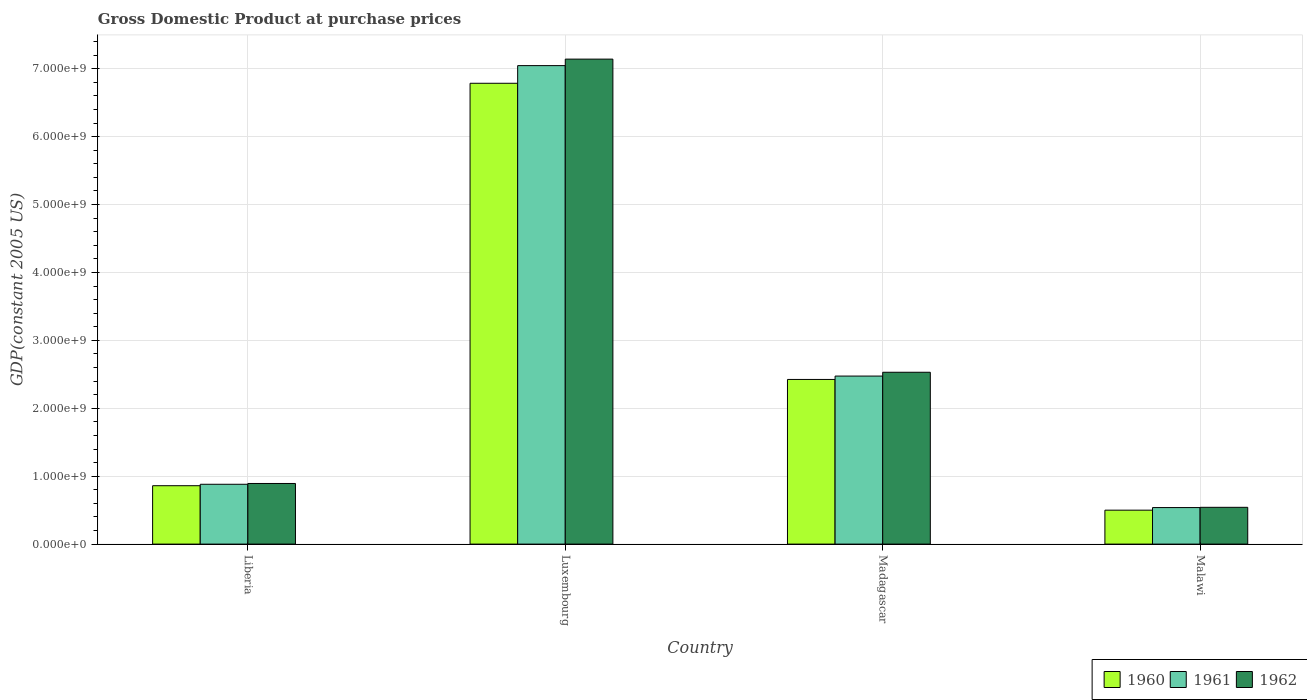How many different coloured bars are there?
Your answer should be very brief. 3. Are the number of bars per tick equal to the number of legend labels?
Keep it short and to the point. Yes. Are the number of bars on each tick of the X-axis equal?
Keep it short and to the point. Yes. How many bars are there on the 1st tick from the left?
Make the answer very short. 3. How many bars are there on the 2nd tick from the right?
Your answer should be very brief. 3. What is the label of the 4th group of bars from the left?
Provide a succinct answer. Malawi. What is the GDP at purchase prices in 1961 in Malawi?
Give a very brief answer. 5.38e+08. Across all countries, what is the maximum GDP at purchase prices in 1961?
Offer a terse response. 7.05e+09. Across all countries, what is the minimum GDP at purchase prices in 1961?
Offer a terse response. 5.38e+08. In which country was the GDP at purchase prices in 1962 maximum?
Make the answer very short. Luxembourg. In which country was the GDP at purchase prices in 1960 minimum?
Offer a terse response. Malawi. What is the total GDP at purchase prices in 1961 in the graph?
Provide a succinct answer. 1.09e+1. What is the difference between the GDP at purchase prices in 1961 in Luxembourg and that in Malawi?
Offer a terse response. 6.51e+09. What is the difference between the GDP at purchase prices in 1961 in Madagascar and the GDP at purchase prices in 1962 in Liberia?
Provide a short and direct response. 1.58e+09. What is the average GDP at purchase prices in 1961 per country?
Keep it short and to the point. 2.73e+09. What is the difference between the GDP at purchase prices of/in 1961 and GDP at purchase prices of/in 1962 in Madagascar?
Ensure brevity in your answer.  -5.62e+07. In how many countries, is the GDP at purchase prices in 1961 greater than 2800000000 US$?
Keep it short and to the point. 1. What is the ratio of the GDP at purchase prices in 1962 in Liberia to that in Luxembourg?
Your response must be concise. 0.13. Is the GDP at purchase prices in 1962 in Liberia less than that in Madagascar?
Offer a terse response. Yes. What is the difference between the highest and the second highest GDP at purchase prices in 1960?
Give a very brief answer. 1.56e+09. What is the difference between the highest and the lowest GDP at purchase prices in 1960?
Offer a terse response. 6.29e+09. In how many countries, is the GDP at purchase prices in 1960 greater than the average GDP at purchase prices in 1960 taken over all countries?
Offer a terse response. 1. Is the sum of the GDP at purchase prices in 1961 in Liberia and Luxembourg greater than the maximum GDP at purchase prices in 1960 across all countries?
Your answer should be compact. Yes. What does the 3rd bar from the right in Liberia represents?
Give a very brief answer. 1960. Is it the case that in every country, the sum of the GDP at purchase prices in 1962 and GDP at purchase prices in 1960 is greater than the GDP at purchase prices in 1961?
Keep it short and to the point. Yes. How many bars are there?
Make the answer very short. 12. How many countries are there in the graph?
Your answer should be compact. 4. What is the difference between two consecutive major ticks on the Y-axis?
Ensure brevity in your answer.  1.00e+09. Does the graph contain any zero values?
Your answer should be very brief. No. Where does the legend appear in the graph?
Provide a short and direct response. Bottom right. What is the title of the graph?
Offer a very short reply. Gross Domestic Product at purchase prices. What is the label or title of the X-axis?
Provide a succinct answer. Country. What is the label or title of the Y-axis?
Provide a short and direct response. GDP(constant 2005 US). What is the GDP(constant 2005 US) of 1960 in Liberia?
Your answer should be very brief. 8.60e+08. What is the GDP(constant 2005 US) of 1961 in Liberia?
Make the answer very short. 8.81e+08. What is the GDP(constant 2005 US) in 1962 in Liberia?
Make the answer very short. 8.93e+08. What is the GDP(constant 2005 US) in 1960 in Luxembourg?
Offer a very short reply. 6.79e+09. What is the GDP(constant 2005 US) in 1961 in Luxembourg?
Provide a succinct answer. 7.05e+09. What is the GDP(constant 2005 US) in 1962 in Luxembourg?
Make the answer very short. 7.14e+09. What is the GDP(constant 2005 US) in 1960 in Madagascar?
Give a very brief answer. 2.42e+09. What is the GDP(constant 2005 US) of 1961 in Madagascar?
Provide a short and direct response. 2.47e+09. What is the GDP(constant 2005 US) of 1962 in Madagascar?
Offer a very short reply. 2.53e+09. What is the GDP(constant 2005 US) of 1960 in Malawi?
Ensure brevity in your answer.  5.00e+08. What is the GDP(constant 2005 US) in 1961 in Malawi?
Provide a succinct answer. 5.38e+08. What is the GDP(constant 2005 US) in 1962 in Malawi?
Provide a short and direct response. 5.42e+08. Across all countries, what is the maximum GDP(constant 2005 US) of 1960?
Offer a very short reply. 6.79e+09. Across all countries, what is the maximum GDP(constant 2005 US) of 1961?
Provide a short and direct response. 7.05e+09. Across all countries, what is the maximum GDP(constant 2005 US) in 1962?
Make the answer very short. 7.14e+09. Across all countries, what is the minimum GDP(constant 2005 US) of 1960?
Give a very brief answer. 5.00e+08. Across all countries, what is the minimum GDP(constant 2005 US) in 1961?
Give a very brief answer. 5.38e+08. Across all countries, what is the minimum GDP(constant 2005 US) of 1962?
Your answer should be very brief. 5.42e+08. What is the total GDP(constant 2005 US) of 1960 in the graph?
Give a very brief answer. 1.06e+1. What is the total GDP(constant 2005 US) of 1961 in the graph?
Keep it short and to the point. 1.09e+1. What is the total GDP(constant 2005 US) in 1962 in the graph?
Your answer should be compact. 1.11e+1. What is the difference between the GDP(constant 2005 US) in 1960 in Liberia and that in Luxembourg?
Offer a very short reply. -5.93e+09. What is the difference between the GDP(constant 2005 US) in 1961 in Liberia and that in Luxembourg?
Your response must be concise. -6.16e+09. What is the difference between the GDP(constant 2005 US) in 1962 in Liberia and that in Luxembourg?
Provide a succinct answer. -6.25e+09. What is the difference between the GDP(constant 2005 US) in 1960 in Liberia and that in Madagascar?
Keep it short and to the point. -1.56e+09. What is the difference between the GDP(constant 2005 US) in 1961 in Liberia and that in Madagascar?
Ensure brevity in your answer.  -1.59e+09. What is the difference between the GDP(constant 2005 US) of 1962 in Liberia and that in Madagascar?
Ensure brevity in your answer.  -1.64e+09. What is the difference between the GDP(constant 2005 US) of 1960 in Liberia and that in Malawi?
Ensure brevity in your answer.  3.60e+08. What is the difference between the GDP(constant 2005 US) in 1961 in Liberia and that in Malawi?
Provide a succinct answer. 3.43e+08. What is the difference between the GDP(constant 2005 US) of 1962 in Liberia and that in Malawi?
Make the answer very short. 3.51e+08. What is the difference between the GDP(constant 2005 US) in 1960 in Luxembourg and that in Madagascar?
Offer a terse response. 4.36e+09. What is the difference between the GDP(constant 2005 US) of 1961 in Luxembourg and that in Madagascar?
Provide a short and direct response. 4.57e+09. What is the difference between the GDP(constant 2005 US) of 1962 in Luxembourg and that in Madagascar?
Provide a short and direct response. 4.61e+09. What is the difference between the GDP(constant 2005 US) of 1960 in Luxembourg and that in Malawi?
Make the answer very short. 6.29e+09. What is the difference between the GDP(constant 2005 US) in 1961 in Luxembourg and that in Malawi?
Your answer should be very brief. 6.51e+09. What is the difference between the GDP(constant 2005 US) in 1962 in Luxembourg and that in Malawi?
Your answer should be very brief. 6.60e+09. What is the difference between the GDP(constant 2005 US) of 1960 in Madagascar and that in Malawi?
Your answer should be very brief. 1.92e+09. What is the difference between the GDP(constant 2005 US) in 1961 in Madagascar and that in Malawi?
Make the answer very short. 1.94e+09. What is the difference between the GDP(constant 2005 US) in 1962 in Madagascar and that in Malawi?
Offer a terse response. 1.99e+09. What is the difference between the GDP(constant 2005 US) in 1960 in Liberia and the GDP(constant 2005 US) in 1961 in Luxembourg?
Keep it short and to the point. -6.19e+09. What is the difference between the GDP(constant 2005 US) of 1960 in Liberia and the GDP(constant 2005 US) of 1962 in Luxembourg?
Your response must be concise. -6.28e+09. What is the difference between the GDP(constant 2005 US) in 1961 in Liberia and the GDP(constant 2005 US) in 1962 in Luxembourg?
Offer a very short reply. -6.26e+09. What is the difference between the GDP(constant 2005 US) in 1960 in Liberia and the GDP(constant 2005 US) in 1961 in Madagascar?
Your answer should be very brief. -1.61e+09. What is the difference between the GDP(constant 2005 US) in 1960 in Liberia and the GDP(constant 2005 US) in 1962 in Madagascar?
Give a very brief answer. -1.67e+09. What is the difference between the GDP(constant 2005 US) in 1961 in Liberia and the GDP(constant 2005 US) in 1962 in Madagascar?
Ensure brevity in your answer.  -1.65e+09. What is the difference between the GDP(constant 2005 US) of 1960 in Liberia and the GDP(constant 2005 US) of 1961 in Malawi?
Make the answer very short. 3.22e+08. What is the difference between the GDP(constant 2005 US) in 1960 in Liberia and the GDP(constant 2005 US) in 1962 in Malawi?
Provide a short and direct response. 3.18e+08. What is the difference between the GDP(constant 2005 US) of 1961 in Liberia and the GDP(constant 2005 US) of 1962 in Malawi?
Your response must be concise. 3.39e+08. What is the difference between the GDP(constant 2005 US) of 1960 in Luxembourg and the GDP(constant 2005 US) of 1961 in Madagascar?
Give a very brief answer. 4.31e+09. What is the difference between the GDP(constant 2005 US) of 1960 in Luxembourg and the GDP(constant 2005 US) of 1962 in Madagascar?
Your answer should be very brief. 4.26e+09. What is the difference between the GDP(constant 2005 US) in 1961 in Luxembourg and the GDP(constant 2005 US) in 1962 in Madagascar?
Offer a very short reply. 4.52e+09. What is the difference between the GDP(constant 2005 US) in 1960 in Luxembourg and the GDP(constant 2005 US) in 1961 in Malawi?
Your answer should be compact. 6.25e+09. What is the difference between the GDP(constant 2005 US) of 1960 in Luxembourg and the GDP(constant 2005 US) of 1962 in Malawi?
Provide a succinct answer. 6.24e+09. What is the difference between the GDP(constant 2005 US) in 1961 in Luxembourg and the GDP(constant 2005 US) in 1962 in Malawi?
Ensure brevity in your answer.  6.50e+09. What is the difference between the GDP(constant 2005 US) in 1960 in Madagascar and the GDP(constant 2005 US) in 1961 in Malawi?
Your answer should be very brief. 1.89e+09. What is the difference between the GDP(constant 2005 US) in 1960 in Madagascar and the GDP(constant 2005 US) in 1962 in Malawi?
Make the answer very short. 1.88e+09. What is the difference between the GDP(constant 2005 US) in 1961 in Madagascar and the GDP(constant 2005 US) in 1962 in Malawi?
Your answer should be compact. 1.93e+09. What is the average GDP(constant 2005 US) in 1960 per country?
Offer a very short reply. 2.64e+09. What is the average GDP(constant 2005 US) of 1961 per country?
Provide a succinct answer. 2.73e+09. What is the average GDP(constant 2005 US) in 1962 per country?
Make the answer very short. 2.78e+09. What is the difference between the GDP(constant 2005 US) in 1960 and GDP(constant 2005 US) in 1961 in Liberia?
Your answer should be compact. -2.10e+07. What is the difference between the GDP(constant 2005 US) in 1960 and GDP(constant 2005 US) in 1962 in Liberia?
Provide a short and direct response. -3.28e+07. What is the difference between the GDP(constant 2005 US) in 1961 and GDP(constant 2005 US) in 1962 in Liberia?
Provide a short and direct response. -1.18e+07. What is the difference between the GDP(constant 2005 US) of 1960 and GDP(constant 2005 US) of 1961 in Luxembourg?
Your answer should be very brief. -2.60e+08. What is the difference between the GDP(constant 2005 US) of 1960 and GDP(constant 2005 US) of 1962 in Luxembourg?
Ensure brevity in your answer.  -3.56e+08. What is the difference between the GDP(constant 2005 US) in 1961 and GDP(constant 2005 US) in 1962 in Luxembourg?
Your response must be concise. -9.57e+07. What is the difference between the GDP(constant 2005 US) of 1960 and GDP(constant 2005 US) of 1961 in Madagascar?
Ensure brevity in your answer.  -4.97e+07. What is the difference between the GDP(constant 2005 US) in 1960 and GDP(constant 2005 US) in 1962 in Madagascar?
Your answer should be compact. -1.06e+08. What is the difference between the GDP(constant 2005 US) of 1961 and GDP(constant 2005 US) of 1962 in Madagascar?
Give a very brief answer. -5.62e+07. What is the difference between the GDP(constant 2005 US) in 1960 and GDP(constant 2005 US) in 1961 in Malawi?
Your answer should be compact. -3.82e+07. What is the difference between the GDP(constant 2005 US) of 1960 and GDP(constant 2005 US) of 1962 in Malawi?
Your answer should be compact. -4.18e+07. What is the difference between the GDP(constant 2005 US) in 1961 and GDP(constant 2005 US) in 1962 in Malawi?
Your answer should be compact. -3.60e+06. What is the ratio of the GDP(constant 2005 US) of 1960 in Liberia to that in Luxembourg?
Provide a succinct answer. 0.13. What is the ratio of the GDP(constant 2005 US) in 1961 in Liberia to that in Luxembourg?
Ensure brevity in your answer.  0.12. What is the ratio of the GDP(constant 2005 US) in 1962 in Liberia to that in Luxembourg?
Your answer should be very brief. 0.12. What is the ratio of the GDP(constant 2005 US) in 1960 in Liberia to that in Madagascar?
Your response must be concise. 0.35. What is the ratio of the GDP(constant 2005 US) in 1961 in Liberia to that in Madagascar?
Provide a short and direct response. 0.36. What is the ratio of the GDP(constant 2005 US) of 1962 in Liberia to that in Madagascar?
Your answer should be very brief. 0.35. What is the ratio of the GDP(constant 2005 US) in 1960 in Liberia to that in Malawi?
Make the answer very short. 1.72. What is the ratio of the GDP(constant 2005 US) in 1961 in Liberia to that in Malawi?
Your response must be concise. 1.64. What is the ratio of the GDP(constant 2005 US) in 1962 in Liberia to that in Malawi?
Make the answer very short. 1.65. What is the ratio of the GDP(constant 2005 US) of 1960 in Luxembourg to that in Madagascar?
Your response must be concise. 2.8. What is the ratio of the GDP(constant 2005 US) in 1961 in Luxembourg to that in Madagascar?
Keep it short and to the point. 2.85. What is the ratio of the GDP(constant 2005 US) in 1962 in Luxembourg to that in Madagascar?
Your response must be concise. 2.82. What is the ratio of the GDP(constant 2005 US) of 1960 in Luxembourg to that in Malawi?
Your answer should be very brief. 13.58. What is the ratio of the GDP(constant 2005 US) in 1961 in Luxembourg to that in Malawi?
Provide a short and direct response. 13.1. What is the ratio of the GDP(constant 2005 US) of 1962 in Luxembourg to that in Malawi?
Your answer should be very brief. 13.19. What is the ratio of the GDP(constant 2005 US) in 1960 in Madagascar to that in Malawi?
Ensure brevity in your answer.  4.85. What is the ratio of the GDP(constant 2005 US) of 1961 in Madagascar to that in Malawi?
Keep it short and to the point. 4.6. What is the ratio of the GDP(constant 2005 US) of 1962 in Madagascar to that in Malawi?
Provide a succinct answer. 4.67. What is the difference between the highest and the second highest GDP(constant 2005 US) in 1960?
Ensure brevity in your answer.  4.36e+09. What is the difference between the highest and the second highest GDP(constant 2005 US) of 1961?
Your answer should be very brief. 4.57e+09. What is the difference between the highest and the second highest GDP(constant 2005 US) in 1962?
Provide a short and direct response. 4.61e+09. What is the difference between the highest and the lowest GDP(constant 2005 US) in 1960?
Offer a terse response. 6.29e+09. What is the difference between the highest and the lowest GDP(constant 2005 US) in 1961?
Ensure brevity in your answer.  6.51e+09. What is the difference between the highest and the lowest GDP(constant 2005 US) in 1962?
Give a very brief answer. 6.60e+09. 